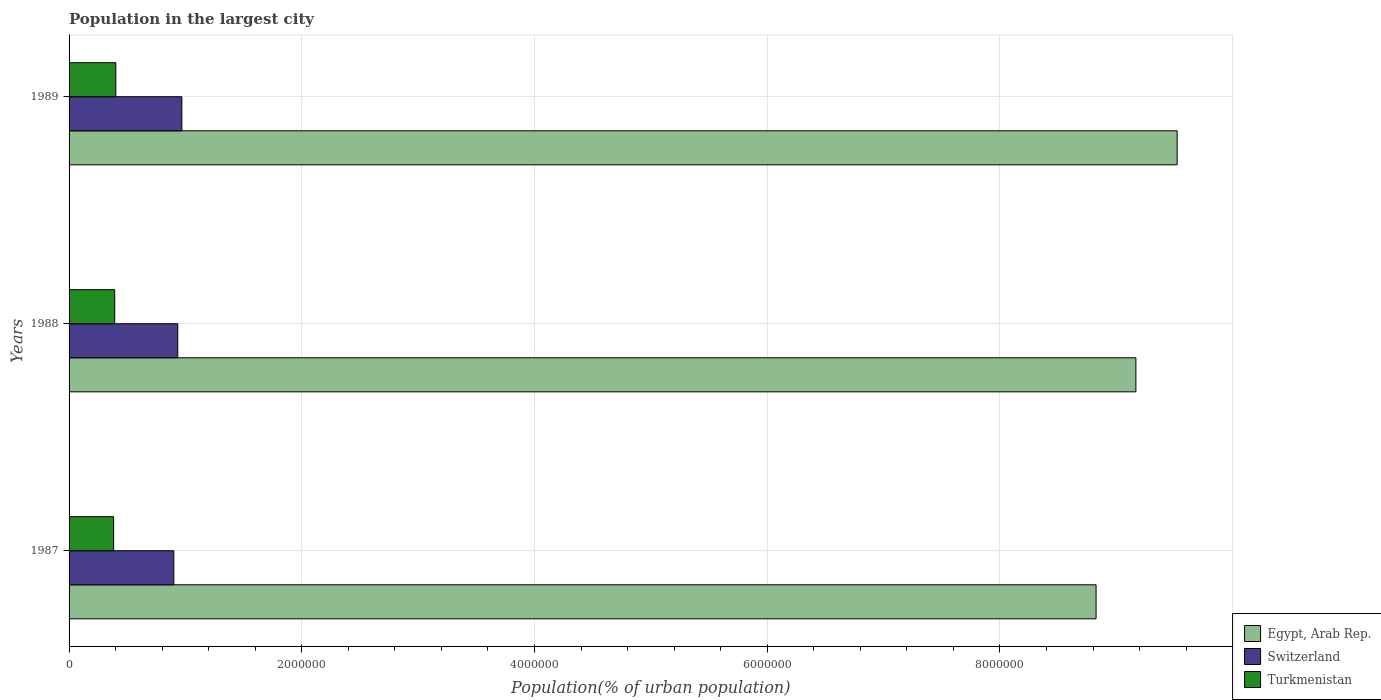Are the number of bars on each tick of the Y-axis equal?
Provide a short and direct response. Yes. How many bars are there on the 1st tick from the bottom?
Give a very brief answer. 3. What is the population in the largest city in Egypt, Arab Rep. in 1987?
Your answer should be compact. 8.83e+06. Across all years, what is the maximum population in the largest city in Switzerland?
Offer a terse response. 9.69e+05. Across all years, what is the minimum population in the largest city in Switzerland?
Provide a succinct answer. 9.00e+05. In which year was the population in the largest city in Egypt, Arab Rep. maximum?
Provide a short and direct response. 1989. In which year was the population in the largest city in Switzerland minimum?
Offer a very short reply. 1987. What is the total population in the largest city in Switzerland in the graph?
Your answer should be compact. 2.80e+06. What is the difference between the population in the largest city in Egypt, Arab Rep. in 1987 and that in 1988?
Keep it short and to the point. -3.42e+05. What is the difference between the population in the largest city in Turkmenistan in 1987 and the population in the largest city in Switzerland in 1989?
Make the answer very short. -5.87e+05. What is the average population in the largest city in Turkmenistan per year?
Ensure brevity in your answer.  3.92e+05. In the year 1988, what is the difference between the population in the largest city in Switzerland and population in the largest city in Turkmenistan?
Your answer should be very brief. 5.42e+05. What is the ratio of the population in the largest city in Switzerland in 1987 to that in 1988?
Offer a terse response. 0.96. Is the difference between the population in the largest city in Switzerland in 1987 and 1988 greater than the difference between the population in the largest city in Turkmenistan in 1987 and 1988?
Keep it short and to the point. No. What is the difference between the highest and the second highest population in the largest city in Egypt, Arab Rep.?
Offer a terse response. 3.55e+05. What is the difference between the highest and the lowest population in the largest city in Egypt, Arab Rep.?
Provide a short and direct response. 6.97e+05. Is the sum of the population in the largest city in Switzerland in 1988 and 1989 greater than the maximum population in the largest city in Egypt, Arab Rep. across all years?
Offer a very short reply. No. What does the 1st bar from the top in 1988 represents?
Make the answer very short. Turkmenistan. What does the 3rd bar from the bottom in 1989 represents?
Offer a terse response. Turkmenistan. How many bars are there?
Provide a succinct answer. 9. Are all the bars in the graph horizontal?
Your answer should be very brief. Yes. Are the values on the major ticks of X-axis written in scientific E-notation?
Your response must be concise. No. Does the graph contain any zero values?
Your response must be concise. No. Does the graph contain grids?
Keep it short and to the point. Yes. How many legend labels are there?
Keep it short and to the point. 3. What is the title of the graph?
Make the answer very short. Population in the largest city. Does "Mongolia" appear as one of the legend labels in the graph?
Provide a short and direct response. No. What is the label or title of the X-axis?
Provide a short and direct response. Population(% of urban population). What is the label or title of the Y-axis?
Your response must be concise. Years. What is the Population(% of urban population) of Egypt, Arab Rep. in 1987?
Offer a very short reply. 8.83e+06. What is the Population(% of urban population) of Switzerland in 1987?
Offer a terse response. 9.00e+05. What is the Population(% of urban population) of Turkmenistan in 1987?
Make the answer very short. 3.83e+05. What is the Population(% of urban population) in Egypt, Arab Rep. in 1988?
Provide a succinct answer. 9.17e+06. What is the Population(% of urban population) in Switzerland in 1988?
Offer a terse response. 9.34e+05. What is the Population(% of urban population) of Turkmenistan in 1988?
Keep it short and to the point. 3.92e+05. What is the Population(% of urban population) in Egypt, Arab Rep. in 1989?
Your response must be concise. 9.52e+06. What is the Population(% of urban population) of Switzerland in 1989?
Make the answer very short. 9.69e+05. What is the Population(% of urban population) in Turkmenistan in 1989?
Offer a very short reply. 4.02e+05. Across all years, what is the maximum Population(% of urban population) of Egypt, Arab Rep.?
Make the answer very short. 9.52e+06. Across all years, what is the maximum Population(% of urban population) of Switzerland?
Your answer should be very brief. 9.69e+05. Across all years, what is the maximum Population(% of urban population) of Turkmenistan?
Provide a short and direct response. 4.02e+05. Across all years, what is the minimum Population(% of urban population) in Egypt, Arab Rep.?
Provide a succinct answer. 8.83e+06. Across all years, what is the minimum Population(% of urban population) of Switzerland?
Offer a very short reply. 9.00e+05. Across all years, what is the minimum Population(% of urban population) of Turkmenistan?
Keep it short and to the point. 3.83e+05. What is the total Population(% of urban population) in Egypt, Arab Rep. in the graph?
Your answer should be compact. 2.75e+07. What is the total Population(% of urban population) of Switzerland in the graph?
Ensure brevity in your answer.  2.80e+06. What is the total Population(% of urban population) of Turkmenistan in the graph?
Provide a succinct answer. 1.18e+06. What is the difference between the Population(% of urban population) of Egypt, Arab Rep. in 1987 and that in 1988?
Provide a short and direct response. -3.42e+05. What is the difference between the Population(% of urban population) in Switzerland in 1987 and that in 1988?
Your answer should be very brief. -3.39e+04. What is the difference between the Population(% of urban population) in Turkmenistan in 1987 and that in 1988?
Offer a terse response. -9384. What is the difference between the Population(% of urban population) of Egypt, Arab Rep. in 1987 and that in 1989?
Your response must be concise. -6.97e+05. What is the difference between the Population(% of urban population) of Switzerland in 1987 and that in 1989?
Provide a short and direct response. -6.90e+04. What is the difference between the Population(% of urban population) of Turkmenistan in 1987 and that in 1989?
Make the answer very short. -1.90e+04. What is the difference between the Population(% of urban population) of Egypt, Arab Rep. in 1988 and that in 1989?
Your answer should be very brief. -3.55e+05. What is the difference between the Population(% of urban population) of Switzerland in 1988 and that in 1989?
Offer a very short reply. -3.51e+04. What is the difference between the Population(% of urban population) of Turkmenistan in 1988 and that in 1989?
Your answer should be very brief. -9587. What is the difference between the Population(% of urban population) in Egypt, Arab Rep. in 1987 and the Population(% of urban population) in Switzerland in 1988?
Your answer should be very brief. 7.89e+06. What is the difference between the Population(% of urban population) of Egypt, Arab Rep. in 1987 and the Population(% of urban population) of Turkmenistan in 1988?
Your response must be concise. 8.43e+06. What is the difference between the Population(% of urban population) of Switzerland in 1987 and the Population(% of urban population) of Turkmenistan in 1988?
Offer a very short reply. 5.08e+05. What is the difference between the Population(% of urban population) of Egypt, Arab Rep. in 1987 and the Population(% of urban population) of Switzerland in 1989?
Your answer should be very brief. 7.86e+06. What is the difference between the Population(% of urban population) of Egypt, Arab Rep. in 1987 and the Population(% of urban population) of Turkmenistan in 1989?
Offer a terse response. 8.42e+06. What is the difference between the Population(% of urban population) in Switzerland in 1987 and the Population(% of urban population) in Turkmenistan in 1989?
Provide a succinct answer. 4.99e+05. What is the difference between the Population(% of urban population) in Egypt, Arab Rep. in 1988 and the Population(% of urban population) in Switzerland in 1989?
Your answer should be very brief. 8.20e+06. What is the difference between the Population(% of urban population) of Egypt, Arab Rep. in 1988 and the Population(% of urban population) of Turkmenistan in 1989?
Your response must be concise. 8.77e+06. What is the difference between the Population(% of urban population) of Switzerland in 1988 and the Population(% of urban population) of Turkmenistan in 1989?
Your answer should be compact. 5.33e+05. What is the average Population(% of urban population) of Egypt, Arab Rep. per year?
Your response must be concise. 9.17e+06. What is the average Population(% of urban population) of Switzerland per year?
Offer a very short reply. 9.35e+05. What is the average Population(% of urban population) of Turkmenistan per year?
Your answer should be very brief. 3.92e+05. In the year 1987, what is the difference between the Population(% of urban population) of Egypt, Arab Rep. and Population(% of urban population) of Switzerland?
Offer a terse response. 7.93e+06. In the year 1987, what is the difference between the Population(% of urban population) in Egypt, Arab Rep. and Population(% of urban population) in Turkmenistan?
Your answer should be very brief. 8.44e+06. In the year 1987, what is the difference between the Population(% of urban population) of Switzerland and Population(% of urban population) of Turkmenistan?
Make the answer very short. 5.18e+05. In the year 1988, what is the difference between the Population(% of urban population) in Egypt, Arab Rep. and Population(% of urban population) in Switzerland?
Your response must be concise. 8.23e+06. In the year 1988, what is the difference between the Population(% of urban population) of Egypt, Arab Rep. and Population(% of urban population) of Turkmenistan?
Provide a short and direct response. 8.78e+06. In the year 1988, what is the difference between the Population(% of urban population) of Switzerland and Population(% of urban population) of Turkmenistan?
Provide a short and direct response. 5.42e+05. In the year 1989, what is the difference between the Population(% of urban population) in Egypt, Arab Rep. and Population(% of urban population) in Switzerland?
Make the answer very short. 8.55e+06. In the year 1989, what is the difference between the Population(% of urban population) of Egypt, Arab Rep. and Population(% of urban population) of Turkmenistan?
Offer a very short reply. 9.12e+06. In the year 1989, what is the difference between the Population(% of urban population) of Switzerland and Population(% of urban population) of Turkmenistan?
Keep it short and to the point. 5.68e+05. What is the ratio of the Population(% of urban population) of Egypt, Arab Rep. in 1987 to that in 1988?
Keep it short and to the point. 0.96. What is the ratio of the Population(% of urban population) in Switzerland in 1987 to that in 1988?
Provide a succinct answer. 0.96. What is the ratio of the Population(% of urban population) of Turkmenistan in 1987 to that in 1988?
Provide a short and direct response. 0.98. What is the ratio of the Population(% of urban population) in Egypt, Arab Rep. in 1987 to that in 1989?
Make the answer very short. 0.93. What is the ratio of the Population(% of urban population) in Switzerland in 1987 to that in 1989?
Provide a short and direct response. 0.93. What is the ratio of the Population(% of urban population) in Turkmenistan in 1987 to that in 1989?
Your answer should be compact. 0.95. What is the ratio of the Population(% of urban population) in Egypt, Arab Rep. in 1988 to that in 1989?
Ensure brevity in your answer.  0.96. What is the ratio of the Population(% of urban population) of Switzerland in 1988 to that in 1989?
Offer a very short reply. 0.96. What is the ratio of the Population(% of urban population) of Turkmenistan in 1988 to that in 1989?
Ensure brevity in your answer.  0.98. What is the difference between the highest and the second highest Population(% of urban population) of Egypt, Arab Rep.?
Provide a short and direct response. 3.55e+05. What is the difference between the highest and the second highest Population(% of urban population) in Switzerland?
Offer a terse response. 3.51e+04. What is the difference between the highest and the second highest Population(% of urban population) in Turkmenistan?
Your answer should be compact. 9587. What is the difference between the highest and the lowest Population(% of urban population) in Egypt, Arab Rep.?
Offer a terse response. 6.97e+05. What is the difference between the highest and the lowest Population(% of urban population) in Switzerland?
Your answer should be very brief. 6.90e+04. What is the difference between the highest and the lowest Population(% of urban population) of Turkmenistan?
Provide a succinct answer. 1.90e+04. 